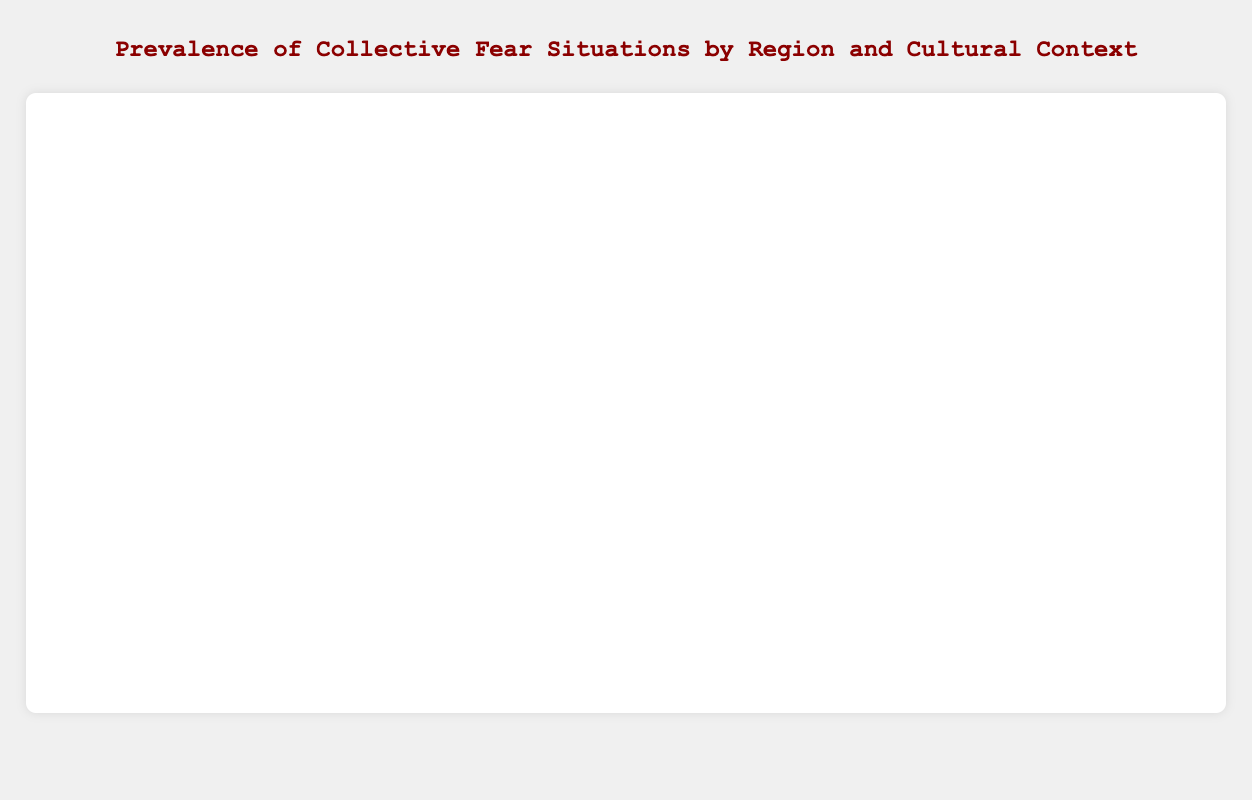What context has the highest prevalence of collective fear in North America? By examining the bar heights for North America, "Pandemic Outbreak" has the highest prevalence portrayed by the longest bar in its category.
Answer: Pandemic Outbreak Which regions have a higher prevalence of collective fear regarding economic issues? Compare the prevalence values for contexts related to economic issues across regions; North America has 60 (Economic Recession), Asia 72 (Economic Instability), and South America 66 (Economic Instability). Asia has the highest prevalence in economic issues.
Answer: Asia What is the total prevalence of collective fear situations in Africa? Add all the prevalence values for Africa: 77 (Political Instability) + 81 (Epidemic Outbreak) + 74 (Food Insecurity). Total prevalence = 77 + 81 + 74 = 232.
Answer: 232 Which situation in Europe has the lowest prevalence of collective fear and what's its value? Observe the bar lengths for Europe and find that "Refugee Crisis" has the shortest bar with a prevalence of 65.
Answer: Refugee Crisis, 65 How does the prevalence of "Pandemic Outbreak" in Asia compare to North America? Compare the bar heights: "Pandemic Outbreak" in Asia has a prevalence of 85 and in North America, it's 82. Asia has a higher prevalence.
Answer: Asia is higher Which context has a prevalence value of 70, and in which region is it located? Look for the bar with a prevalence of 70, which is in Europe for "Climate Change".
Answer: Europe, Climate Change What is the average prevalence of "Pandemic Outbreak" across all regions? Calculate the average for "Pandemic Outbreak": (82 in North America + 85 in Asia) / 2 = 167 / 2 = 83.5.
Answer: 83.5 If you sum the prevalence of "Terrorist Attacks" in North America and Europe, what do you get? Add the prevalence values for "Terrorist Attacks": North America 75 + Europe 68 = 143.
Answer: 143 Which regions are represented by red-hued bars? Identify the bars colored in red, typically representing specific contexts: "Economic Instability" in South America and "Terrorist Attacks" in North America.
Answer: South America, North America 